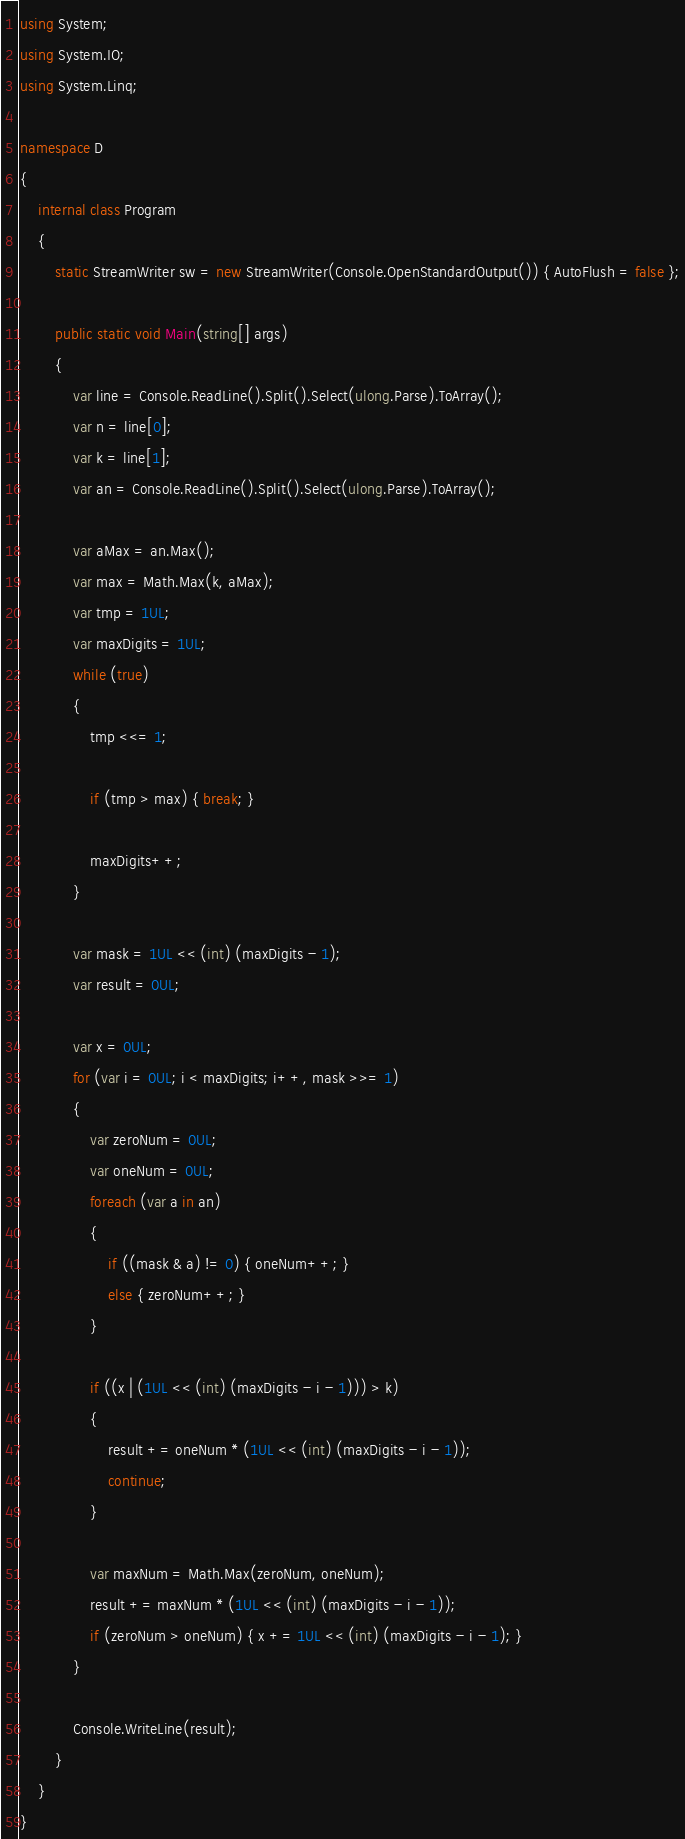<code> <loc_0><loc_0><loc_500><loc_500><_C#_>using System;
using System.IO;
using System.Linq;
 
namespace D
{
	internal class Program
	{
		static StreamWriter sw = new StreamWriter(Console.OpenStandardOutput()) { AutoFlush = false };
 
		public static void Main(string[] args)
		{
			var line = Console.ReadLine().Split().Select(ulong.Parse).ToArray();
			var n = line[0];
			var k = line[1];
			var an = Console.ReadLine().Split().Select(ulong.Parse).ToArray();
 
			var aMax = an.Max();
			var max = Math.Max(k, aMax);
			var tmp = 1UL;
			var maxDigits = 1UL;
			while (true)
			{
				tmp <<= 1;
 
				if (tmp > max) { break; }
 
				maxDigits++;
			}
 
			var mask = 1UL << (int) (maxDigits - 1);
			var result = 0UL;
 
			var x = 0UL;
			for (var i = 0UL; i < maxDigits; i++, mask >>= 1)
			{
				var zeroNum = 0UL;
				var oneNum = 0UL;
				foreach (var a in an)
				{
					if ((mask & a) != 0) { oneNum++; }
					else { zeroNum++; }
				}
 
				if ((x | (1UL << (int) (maxDigits - i - 1))) > k)
				{
					result += oneNum * (1UL << (int) (maxDigits - i - 1));
					continue;
				}
 
				var maxNum = Math.Max(zeroNum, oneNum);
				result += maxNum * (1UL << (int) (maxDigits - i - 1));
				if (zeroNum > oneNum) { x += 1UL << (int) (maxDigits - i - 1); }
			}
 
			Console.WriteLine(result);
		}
	}
}</code> 